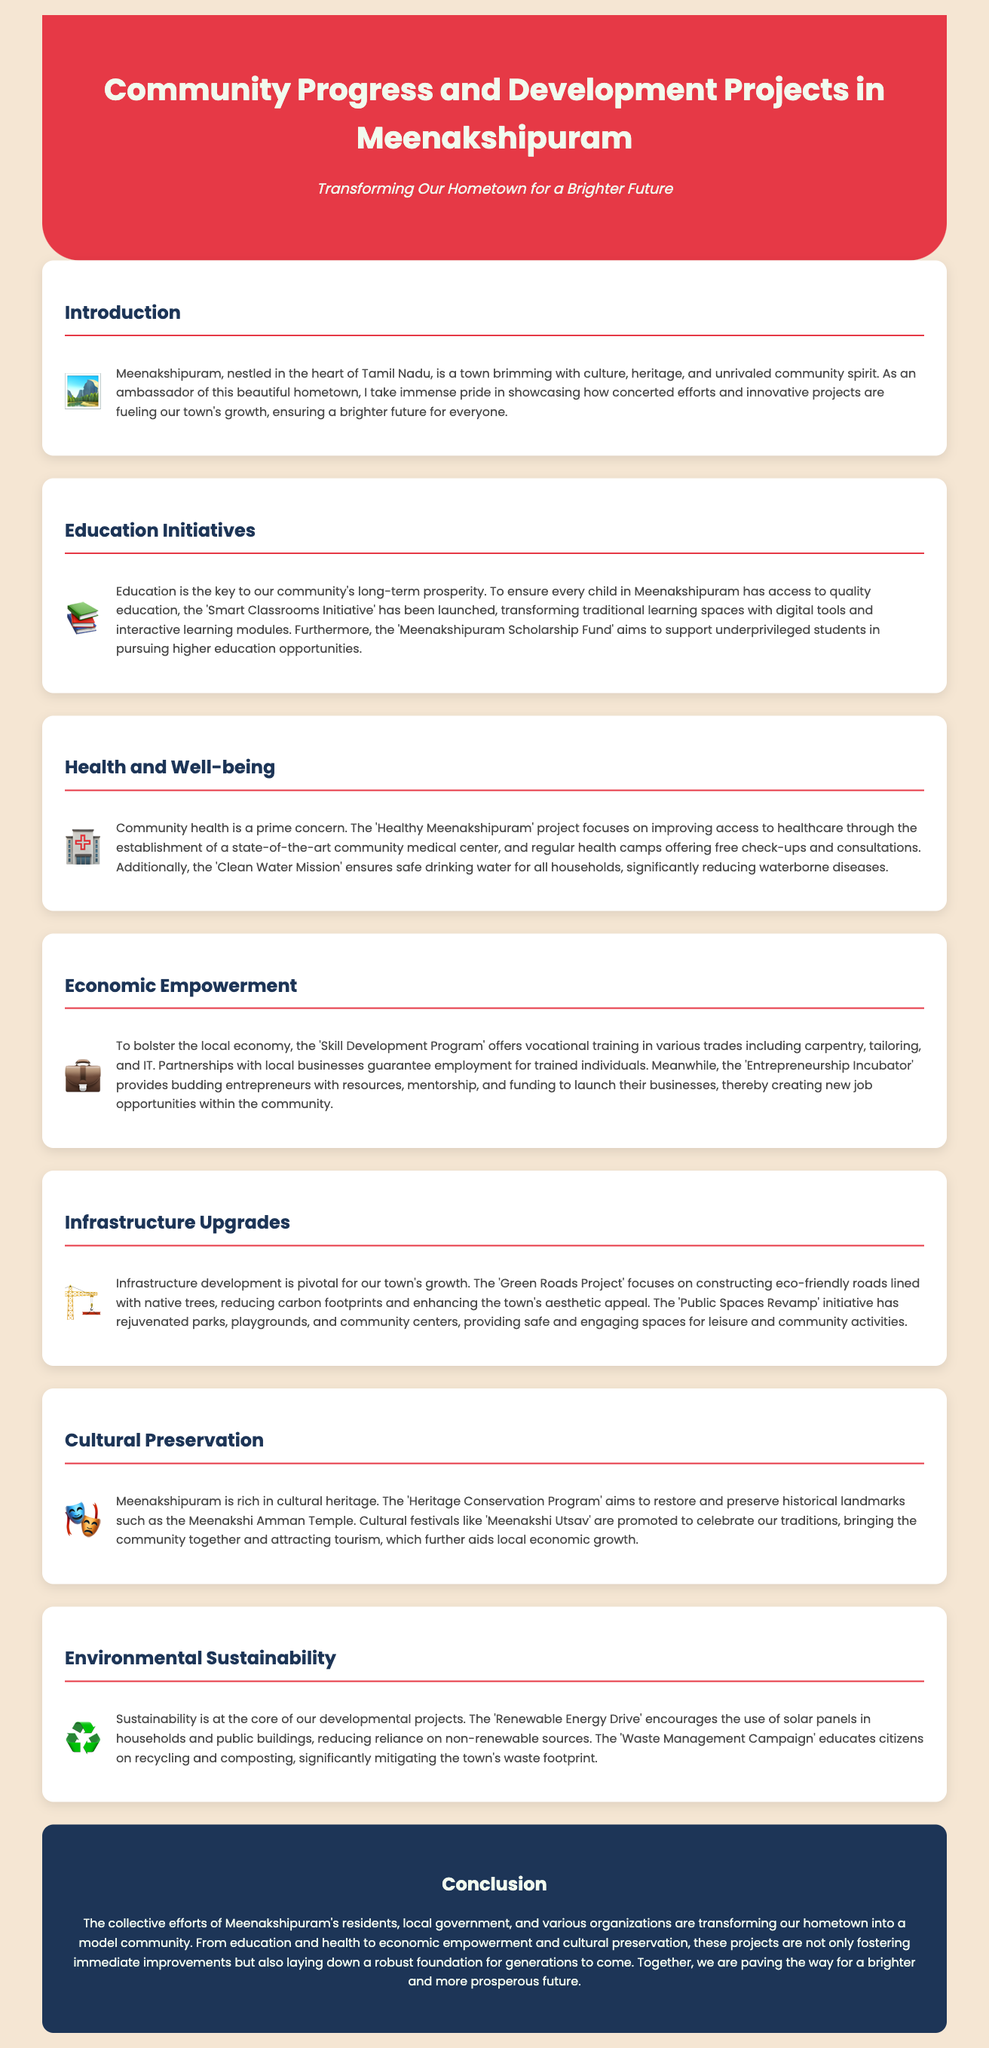what is the title of the infographic? The title, prominently displayed at the top of the infographic, is "Community Progress and Development Projects in Meenakshipuram".
Answer: Community Progress and Development Projects in Meenakshipuram what initiative focuses on education? The initiative specifically highlighted for education is the "Smart Classrooms Initiative".
Answer: Smart Classrooms Initiative what is the main goal of the 'Clean Water Mission'? The main goal of this mission is to ensure safe drinking water for all households.
Answer: safe drinking water how many development areas are mentioned in the document? The document covers six distinct areas related to community development.
Answer: six what project encourages solar panel usage? The project aimed at promoting solar panel usage is the "Renewable Energy Drive".
Answer: Renewable Energy Drive which program supports underprivileged students? The program designed to support underprivileged students is the "Meenakshipuram Scholarship Fund".
Answer: Meenakshipuram Scholarship Fund what is a key feature of the 'Green Roads Project'? A key feature of this project is constructing eco-friendly roads lined with native trees.
Answer: eco-friendly roads what cultural festival is promoted in Meenakshipuram? The cultural festival that is promoted to celebrate traditions is "Meenakshi Utsav".
Answer: Meenakshi Utsav 